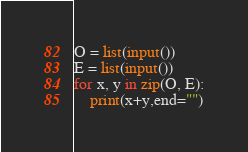Convert code to text. <code><loc_0><loc_0><loc_500><loc_500><_Python_>O = list(input())
E = list(input())
for x, y in zip(O, E):
    print(x+y,end="")</code> 